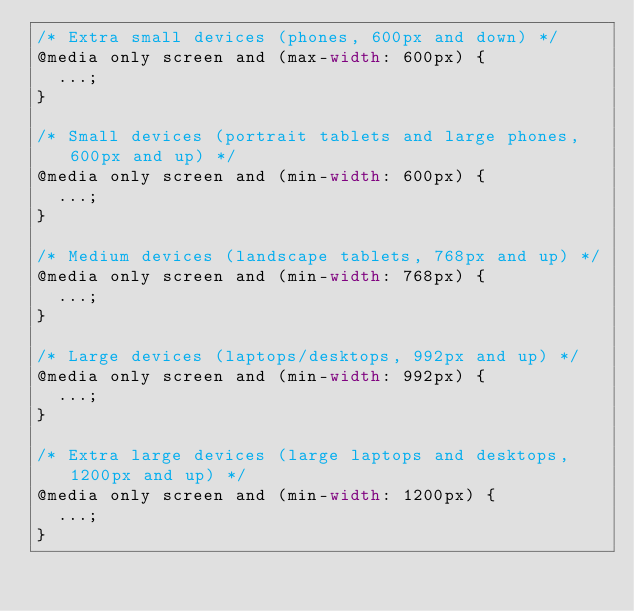<code> <loc_0><loc_0><loc_500><loc_500><_CSS_>/* Extra small devices (phones, 600px and down) */
@media only screen and (max-width: 600px) {
  ...;
}

/* Small devices (portrait tablets and large phones, 600px and up) */
@media only screen and (min-width: 600px) {
  ...;
}

/* Medium devices (landscape tablets, 768px and up) */
@media only screen and (min-width: 768px) {
  ...;
}

/* Large devices (laptops/desktops, 992px and up) */
@media only screen and (min-width: 992px) {
  ...;
}

/* Extra large devices (large laptops and desktops, 1200px and up) */
@media only screen and (min-width: 1200px) {
  ...;
}
</code> 